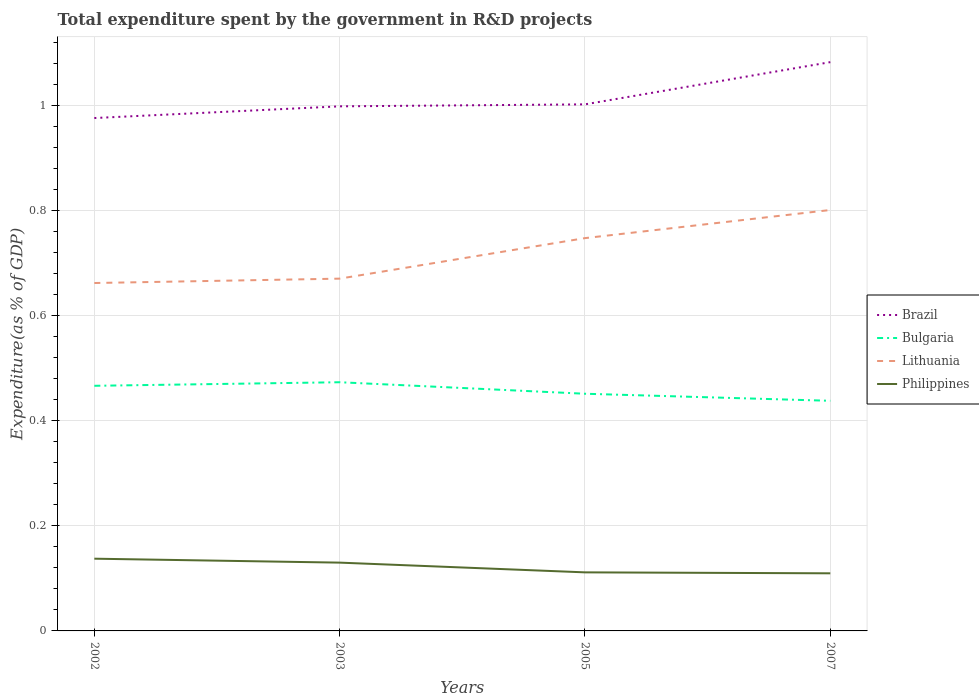How many different coloured lines are there?
Your response must be concise. 4. Does the line corresponding to Brazil intersect with the line corresponding to Philippines?
Your response must be concise. No. Across all years, what is the maximum total expenditure spent by the government in R&D projects in Brazil?
Your response must be concise. 0.98. In which year was the total expenditure spent by the government in R&D projects in Brazil maximum?
Make the answer very short. 2002. What is the total total expenditure spent by the government in R&D projects in Brazil in the graph?
Provide a short and direct response. -0.08. What is the difference between the highest and the second highest total expenditure spent by the government in R&D projects in Lithuania?
Keep it short and to the point. 0.14. Is the total expenditure spent by the government in R&D projects in Philippines strictly greater than the total expenditure spent by the government in R&D projects in Brazil over the years?
Give a very brief answer. Yes. How many lines are there?
Give a very brief answer. 4. Are the values on the major ticks of Y-axis written in scientific E-notation?
Provide a succinct answer. No. Does the graph contain grids?
Your answer should be compact. Yes. How are the legend labels stacked?
Your answer should be compact. Vertical. What is the title of the graph?
Keep it short and to the point. Total expenditure spent by the government in R&D projects. Does "Mongolia" appear as one of the legend labels in the graph?
Provide a short and direct response. No. What is the label or title of the X-axis?
Provide a short and direct response. Years. What is the label or title of the Y-axis?
Give a very brief answer. Expenditure(as % of GDP). What is the Expenditure(as % of GDP) in Brazil in 2002?
Your answer should be very brief. 0.98. What is the Expenditure(as % of GDP) of Bulgaria in 2002?
Offer a very short reply. 0.47. What is the Expenditure(as % of GDP) of Lithuania in 2002?
Provide a short and direct response. 0.66. What is the Expenditure(as % of GDP) of Philippines in 2002?
Your answer should be compact. 0.14. What is the Expenditure(as % of GDP) in Brazil in 2003?
Offer a terse response. 1. What is the Expenditure(as % of GDP) in Bulgaria in 2003?
Offer a terse response. 0.47. What is the Expenditure(as % of GDP) of Lithuania in 2003?
Provide a succinct answer. 0.67. What is the Expenditure(as % of GDP) in Philippines in 2003?
Give a very brief answer. 0.13. What is the Expenditure(as % of GDP) of Brazil in 2005?
Provide a short and direct response. 1. What is the Expenditure(as % of GDP) in Bulgaria in 2005?
Keep it short and to the point. 0.45. What is the Expenditure(as % of GDP) in Lithuania in 2005?
Provide a succinct answer. 0.75. What is the Expenditure(as % of GDP) in Philippines in 2005?
Ensure brevity in your answer.  0.11. What is the Expenditure(as % of GDP) of Brazil in 2007?
Make the answer very short. 1.08. What is the Expenditure(as % of GDP) of Bulgaria in 2007?
Your response must be concise. 0.44. What is the Expenditure(as % of GDP) of Lithuania in 2007?
Offer a terse response. 0.8. What is the Expenditure(as % of GDP) of Philippines in 2007?
Your response must be concise. 0.11. Across all years, what is the maximum Expenditure(as % of GDP) in Brazil?
Provide a short and direct response. 1.08. Across all years, what is the maximum Expenditure(as % of GDP) in Bulgaria?
Your answer should be very brief. 0.47. Across all years, what is the maximum Expenditure(as % of GDP) in Lithuania?
Give a very brief answer. 0.8. Across all years, what is the maximum Expenditure(as % of GDP) in Philippines?
Make the answer very short. 0.14. Across all years, what is the minimum Expenditure(as % of GDP) in Brazil?
Offer a terse response. 0.98. Across all years, what is the minimum Expenditure(as % of GDP) of Bulgaria?
Offer a very short reply. 0.44. Across all years, what is the minimum Expenditure(as % of GDP) of Lithuania?
Your answer should be compact. 0.66. Across all years, what is the minimum Expenditure(as % of GDP) in Philippines?
Your answer should be very brief. 0.11. What is the total Expenditure(as % of GDP) of Brazil in the graph?
Make the answer very short. 4.06. What is the total Expenditure(as % of GDP) in Bulgaria in the graph?
Ensure brevity in your answer.  1.83. What is the total Expenditure(as % of GDP) in Lithuania in the graph?
Give a very brief answer. 2.88. What is the total Expenditure(as % of GDP) in Philippines in the graph?
Keep it short and to the point. 0.49. What is the difference between the Expenditure(as % of GDP) in Brazil in 2002 and that in 2003?
Your answer should be compact. -0.02. What is the difference between the Expenditure(as % of GDP) in Bulgaria in 2002 and that in 2003?
Your response must be concise. -0.01. What is the difference between the Expenditure(as % of GDP) in Lithuania in 2002 and that in 2003?
Your answer should be very brief. -0.01. What is the difference between the Expenditure(as % of GDP) of Philippines in 2002 and that in 2003?
Offer a very short reply. 0.01. What is the difference between the Expenditure(as % of GDP) of Brazil in 2002 and that in 2005?
Your response must be concise. -0.03. What is the difference between the Expenditure(as % of GDP) in Bulgaria in 2002 and that in 2005?
Provide a succinct answer. 0.02. What is the difference between the Expenditure(as % of GDP) of Lithuania in 2002 and that in 2005?
Your answer should be very brief. -0.09. What is the difference between the Expenditure(as % of GDP) in Philippines in 2002 and that in 2005?
Make the answer very short. 0.03. What is the difference between the Expenditure(as % of GDP) in Brazil in 2002 and that in 2007?
Keep it short and to the point. -0.11. What is the difference between the Expenditure(as % of GDP) in Bulgaria in 2002 and that in 2007?
Ensure brevity in your answer.  0.03. What is the difference between the Expenditure(as % of GDP) of Lithuania in 2002 and that in 2007?
Give a very brief answer. -0.14. What is the difference between the Expenditure(as % of GDP) in Philippines in 2002 and that in 2007?
Make the answer very short. 0.03. What is the difference between the Expenditure(as % of GDP) of Brazil in 2003 and that in 2005?
Offer a terse response. -0. What is the difference between the Expenditure(as % of GDP) of Bulgaria in 2003 and that in 2005?
Your answer should be compact. 0.02. What is the difference between the Expenditure(as % of GDP) in Lithuania in 2003 and that in 2005?
Your answer should be compact. -0.08. What is the difference between the Expenditure(as % of GDP) of Philippines in 2003 and that in 2005?
Offer a very short reply. 0.02. What is the difference between the Expenditure(as % of GDP) in Brazil in 2003 and that in 2007?
Your response must be concise. -0.08. What is the difference between the Expenditure(as % of GDP) of Bulgaria in 2003 and that in 2007?
Keep it short and to the point. 0.04. What is the difference between the Expenditure(as % of GDP) of Lithuania in 2003 and that in 2007?
Offer a terse response. -0.13. What is the difference between the Expenditure(as % of GDP) of Philippines in 2003 and that in 2007?
Your answer should be very brief. 0.02. What is the difference between the Expenditure(as % of GDP) in Brazil in 2005 and that in 2007?
Make the answer very short. -0.08. What is the difference between the Expenditure(as % of GDP) in Bulgaria in 2005 and that in 2007?
Your answer should be compact. 0.01. What is the difference between the Expenditure(as % of GDP) of Lithuania in 2005 and that in 2007?
Your response must be concise. -0.05. What is the difference between the Expenditure(as % of GDP) in Philippines in 2005 and that in 2007?
Give a very brief answer. 0. What is the difference between the Expenditure(as % of GDP) of Brazil in 2002 and the Expenditure(as % of GDP) of Bulgaria in 2003?
Make the answer very short. 0.5. What is the difference between the Expenditure(as % of GDP) of Brazil in 2002 and the Expenditure(as % of GDP) of Lithuania in 2003?
Provide a succinct answer. 0.31. What is the difference between the Expenditure(as % of GDP) of Brazil in 2002 and the Expenditure(as % of GDP) of Philippines in 2003?
Your response must be concise. 0.85. What is the difference between the Expenditure(as % of GDP) of Bulgaria in 2002 and the Expenditure(as % of GDP) of Lithuania in 2003?
Your response must be concise. -0.2. What is the difference between the Expenditure(as % of GDP) of Bulgaria in 2002 and the Expenditure(as % of GDP) of Philippines in 2003?
Offer a very short reply. 0.34. What is the difference between the Expenditure(as % of GDP) of Lithuania in 2002 and the Expenditure(as % of GDP) of Philippines in 2003?
Make the answer very short. 0.53. What is the difference between the Expenditure(as % of GDP) of Brazil in 2002 and the Expenditure(as % of GDP) of Bulgaria in 2005?
Your answer should be compact. 0.52. What is the difference between the Expenditure(as % of GDP) in Brazil in 2002 and the Expenditure(as % of GDP) in Lithuania in 2005?
Your answer should be very brief. 0.23. What is the difference between the Expenditure(as % of GDP) of Brazil in 2002 and the Expenditure(as % of GDP) of Philippines in 2005?
Offer a terse response. 0.86. What is the difference between the Expenditure(as % of GDP) in Bulgaria in 2002 and the Expenditure(as % of GDP) in Lithuania in 2005?
Keep it short and to the point. -0.28. What is the difference between the Expenditure(as % of GDP) in Bulgaria in 2002 and the Expenditure(as % of GDP) in Philippines in 2005?
Provide a short and direct response. 0.35. What is the difference between the Expenditure(as % of GDP) in Lithuania in 2002 and the Expenditure(as % of GDP) in Philippines in 2005?
Offer a very short reply. 0.55. What is the difference between the Expenditure(as % of GDP) in Brazil in 2002 and the Expenditure(as % of GDP) in Bulgaria in 2007?
Offer a terse response. 0.54. What is the difference between the Expenditure(as % of GDP) in Brazil in 2002 and the Expenditure(as % of GDP) in Lithuania in 2007?
Provide a short and direct response. 0.17. What is the difference between the Expenditure(as % of GDP) of Brazil in 2002 and the Expenditure(as % of GDP) of Philippines in 2007?
Make the answer very short. 0.87. What is the difference between the Expenditure(as % of GDP) in Bulgaria in 2002 and the Expenditure(as % of GDP) in Lithuania in 2007?
Your response must be concise. -0.33. What is the difference between the Expenditure(as % of GDP) of Bulgaria in 2002 and the Expenditure(as % of GDP) of Philippines in 2007?
Your response must be concise. 0.36. What is the difference between the Expenditure(as % of GDP) of Lithuania in 2002 and the Expenditure(as % of GDP) of Philippines in 2007?
Provide a succinct answer. 0.55. What is the difference between the Expenditure(as % of GDP) in Brazil in 2003 and the Expenditure(as % of GDP) in Bulgaria in 2005?
Your answer should be compact. 0.55. What is the difference between the Expenditure(as % of GDP) in Brazil in 2003 and the Expenditure(as % of GDP) in Lithuania in 2005?
Your answer should be compact. 0.25. What is the difference between the Expenditure(as % of GDP) of Brazil in 2003 and the Expenditure(as % of GDP) of Philippines in 2005?
Offer a terse response. 0.89. What is the difference between the Expenditure(as % of GDP) in Bulgaria in 2003 and the Expenditure(as % of GDP) in Lithuania in 2005?
Keep it short and to the point. -0.27. What is the difference between the Expenditure(as % of GDP) in Bulgaria in 2003 and the Expenditure(as % of GDP) in Philippines in 2005?
Make the answer very short. 0.36. What is the difference between the Expenditure(as % of GDP) of Lithuania in 2003 and the Expenditure(as % of GDP) of Philippines in 2005?
Make the answer very short. 0.56. What is the difference between the Expenditure(as % of GDP) in Brazil in 2003 and the Expenditure(as % of GDP) in Bulgaria in 2007?
Your answer should be compact. 0.56. What is the difference between the Expenditure(as % of GDP) in Brazil in 2003 and the Expenditure(as % of GDP) in Lithuania in 2007?
Provide a short and direct response. 0.2. What is the difference between the Expenditure(as % of GDP) of Brazil in 2003 and the Expenditure(as % of GDP) of Philippines in 2007?
Provide a succinct answer. 0.89. What is the difference between the Expenditure(as % of GDP) of Bulgaria in 2003 and the Expenditure(as % of GDP) of Lithuania in 2007?
Ensure brevity in your answer.  -0.33. What is the difference between the Expenditure(as % of GDP) of Bulgaria in 2003 and the Expenditure(as % of GDP) of Philippines in 2007?
Ensure brevity in your answer.  0.36. What is the difference between the Expenditure(as % of GDP) of Lithuania in 2003 and the Expenditure(as % of GDP) of Philippines in 2007?
Your answer should be compact. 0.56. What is the difference between the Expenditure(as % of GDP) of Brazil in 2005 and the Expenditure(as % of GDP) of Bulgaria in 2007?
Provide a succinct answer. 0.56. What is the difference between the Expenditure(as % of GDP) in Brazil in 2005 and the Expenditure(as % of GDP) in Lithuania in 2007?
Ensure brevity in your answer.  0.2. What is the difference between the Expenditure(as % of GDP) in Brazil in 2005 and the Expenditure(as % of GDP) in Philippines in 2007?
Your answer should be very brief. 0.89. What is the difference between the Expenditure(as % of GDP) of Bulgaria in 2005 and the Expenditure(as % of GDP) of Lithuania in 2007?
Make the answer very short. -0.35. What is the difference between the Expenditure(as % of GDP) in Bulgaria in 2005 and the Expenditure(as % of GDP) in Philippines in 2007?
Provide a succinct answer. 0.34. What is the difference between the Expenditure(as % of GDP) of Lithuania in 2005 and the Expenditure(as % of GDP) of Philippines in 2007?
Keep it short and to the point. 0.64. What is the average Expenditure(as % of GDP) in Brazil per year?
Your answer should be compact. 1.01. What is the average Expenditure(as % of GDP) in Bulgaria per year?
Make the answer very short. 0.46. What is the average Expenditure(as % of GDP) of Lithuania per year?
Offer a very short reply. 0.72. What is the average Expenditure(as % of GDP) in Philippines per year?
Provide a short and direct response. 0.12. In the year 2002, what is the difference between the Expenditure(as % of GDP) of Brazil and Expenditure(as % of GDP) of Bulgaria?
Your answer should be compact. 0.51. In the year 2002, what is the difference between the Expenditure(as % of GDP) of Brazil and Expenditure(as % of GDP) of Lithuania?
Your answer should be compact. 0.31. In the year 2002, what is the difference between the Expenditure(as % of GDP) in Brazil and Expenditure(as % of GDP) in Philippines?
Offer a very short reply. 0.84. In the year 2002, what is the difference between the Expenditure(as % of GDP) in Bulgaria and Expenditure(as % of GDP) in Lithuania?
Provide a short and direct response. -0.2. In the year 2002, what is the difference between the Expenditure(as % of GDP) in Bulgaria and Expenditure(as % of GDP) in Philippines?
Offer a very short reply. 0.33. In the year 2002, what is the difference between the Expenditure(as % of GDP) in Lithuania and Expenditure(as % of GDP) in Philippines?
Your answer should be very brief. 0.52. In the year 2003, what is the difference between the Expenditure(as % of GDP) in Brazil and Expenditure(as % of GDP) in Bulgaria?
Provide a succinct answer. 0.53. In the year 2003, what is the difference between the Expenditure(as % of GDP) in Brazil and Expenditure(as % of GDP) in Lithuania?
Offer a very short reply. 0.33. In the year 2003, what is the difference between the Expenditure(as % of GDP) in Brazil and Expenditure(as % of GDP) in Philippines?
Offer a terse response. 0.87. In the year 2003, what is the difference between the Expenditure(as % of GDP) of Bulgaria and Expenditure(as % of GDP) of Lithuania?
Ensure brevity in your answer.  -0.2. In the year 2003, what is the difference between the Expenditure(as % of GDP) in Bulgaria and Expenditure(as % of GDP) in Philippines?
Your answer should be compact. 0.34. In the year 2003, what is the difference between the Expenditure(as % of GDP) in Lithuania and Expenditure(as % of GDP) in Philippines?
Ensure brevity in your answer.  0.54. In the year 2005, what is the difference between the Expenditure(as % of GDP) in Brazil and Expenditure(as % of GDP) in Bulgaria?
Provide a short and direct response. 0.55. In the year 2005, what is the difference between the Expenditure(as % of GDP) in Brazil and Expenditure(as % of GDP) in Lithuania?
Provide a short and direct response. 0.25. In the year 2005, what is the difference between the Expenditure(as % of GDP) of Brazil and Expenditure(as % of GDP) of Philippines?
Offer a terse response. 0.89. In the year 2005, what is the difference between the Expenditure(as % of GDP) of Bulgaria and Expenditure(as % of GDP) of Lithuania?
Offer a very short reply. -0.3. In the year 2005, what is the difference between the Expenditure(as % of GDP) of Bulgaria and Expenditure(as % of GDP) of Philippines?
Give a very brief answer. 0.34. In the year 2005, what is the difference between the Expenditure(as % of GDP) in Lithuania and Expenditure(as % of GDP) in Philippines?
Offer a terse response. 0.64. In the year 2007, what is the difference between the Expenditure(as % of GDP) in Brazil and Expenditure(as % of GDP) in Bulgaria?
Your answer should be compact. 0.64. In the year 2007, what is the difference between the Expenditure(as % of GDP) of Brazil and Expenditure(as % of GDP) of Lithuania?
Your answer should be very brief. 0.28. In the year 2007, what is the difference between the Expenditure(as % of GDP) in Brazil and Expenditure(as % of GDP) in Philippines?
Provide a succinct answer. 0.97. In the year 2007, what is the difference between the Expenditure(as % of GDP) of Bulgaria and Expenditure(as % of GDP) of Lithuania?
Provide a short and direct response. -0.36. In the year 2007, what is the difference between the Expenditure(as % of GDP) in Bulgaria and Expenditure(as % of GDP) in Philippines?
Offer a terse response. 0.33. In the year 2007, what is the difference between the Expenditure(as % of GDP) of Lithuania and Expenditure(as % of GDP) of Philippines?
Keep it short and to the point. 0.69. What is the ratio of the Expenditure(as % of GDP) of Brazil in 2002 to that in 2003?
Ensure brevity in your answer.  0.98. What is the ratio of the Expenditure(as % of GDP) of Bulgaria in 2002 to that in 2003?
Offer a terse response. 0.99. What is the ratio of the Expenditure(as % of GDP) of Lithuania in 2002 to that in 2003?
Offer a terse response. 0.99. What is the ratio of the Expenditure(as % of GDP) of Philippines in 2002 to that in 2003?
Provide a short and direct response. 1.06. What is the ratio of the Expenditure(as % of GDP) in Brazil in 2002 to that in 2005?
Give a very brief answer. 0.97. What is the ratio of the Expenditure(as % of GDP) of Bulgaria in 2002 to that in 2005?
Your response must be concise. 1.03. What is the ratio of the Expenditure(as % of GDP) in Lithuania in 2002 to that in 2005?
Provide a succinct answer. 0.89. What is the ratio of the Expenditure(as % of GDP) of Philippines in 2002 to that in 2005?
Provide a succinct answer. 1.23. What is the ratio of the Expenditure(as % of GDP) of Brazil in 2002 to that in 2007?
Give a very brief answer. 0.9. What is the ratio of the Expenditure(as % of GDP) in Bulgaria in 2002 to that in 2007?
Offer a very short reply. 1.07. What is the ratio of the Expenditure(as % of GDP) of Lithuania in 2002 to that in 2007?
Make the answer very short. 0.83. What is the ratio of the Expenditure(as % of GDP) in Philippines in 2002 to that in 2007?
Make the answer very short. 1.25. What is the ratio of the Expenditure(as % of GDP) of Bulgaria in 2003 to that in 2005?
Make the answer very short. 1.05. What is the ratio of the Expenditure(as % of GDP) of Lithuania in 2003 to that in 2005?
Provide a succinct answer. 0.9. What is the ratio of the Expenditure(as % of GDP) of Philippines in 2003 to that in 2005?
Give a very brief answer. 1.17. What is the ratio of the Expenditure(as % of GDP) in Brazil in 2003 to that in 2007?
Make the answer very short. 0.92. What is the ratio of the Expenditure(as % of GDP) of Bulgaria in 2003 to that in 2007?
Ensure brevity in your answer.  1.08. What is the ratio of the Expenditure(as % of GDP) of Lithuania in 2003 to that in 2007?
Provide a succinct answer. 0.84. What is the ratio of the Expenditure(as % of GDP) of Philippines in 2003 to that in 2007?
Provide a succinct answer. 1.19. What is the ratio of the Expenditure(as % of GDP) of Brazil in 2005 to that in 2007?
Provide a short and direct response. 0.93. What is the ratio of the Expenditure(as % of GDP) in Bulgaria in 2005 to that in 2007?
Make the answer very short. 1.03. What is the ratio of the Expenditure(as % of GDP) in Lithuania in 2005 to that in 2007?
Ensure brevity in your answer.  0.93. What is the ratio of the Expenditure(as % of GDP) of Philippines in 2005 to that in 2007?
Make the answer very short. 1.02. What is the difference between the highest and the second highest Expenditure(as % of GDP) of Brazil?
Ensure brevity in your answer.  0.08. What is the difference between the highest and the second highest Expenditure(as % of GDP) in Bulgaria?
Ensure brevity in your answer.  0.01. What is the difference between the highest and the second highest Expenditure(as % of GDP) of Lithuania?
Your answer should be compact. 0.05. What is the difference between the highest and the second highest Expenditure(as % of GDP) of Philippines?
Provide a succinct answer. 0.01. What is the difference between the highest and the lowest Expenditure(as % of GDP) of Brazil?
Give a very brief answer. 0.11. What is the difference between the highest and the lowest Expenditure(as % of GDP) in Bulgaria?
Offer a terse response. 0.04. What is the difference between the highest and the lowest Expenditure(as % of GDP) of Lithuania?
Provide a succinct answer. 0.14. What is the difference between the highest and the lowest Expenditure(as % of GDP) in Philippines?
Ensure brevity in your answer.  0.03. 